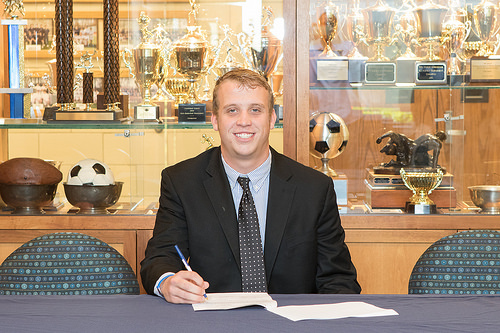<image>
Is there a man on the book? No. The man is not positioned on the book. They may be near each other, but the man is not supported by or resting on top of the book. Is the ball in the bowl? Yes. The ball is contained within or inside the bowl, showing a containment relationship. Is the book above the table? No. The book is not positioned above the table. The vertical arrangement shows a different relationship. 